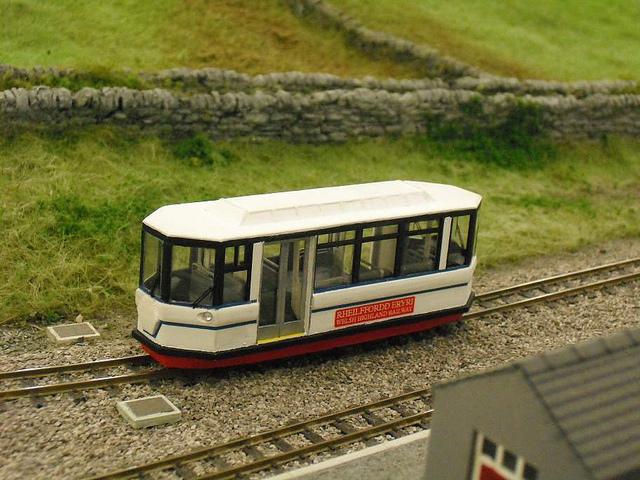What color is the vehicle?
Quick response, please. White. Is the trolley moving?
Concise answer only. No. Are there train tracks?
Answer briefly. Yes. 